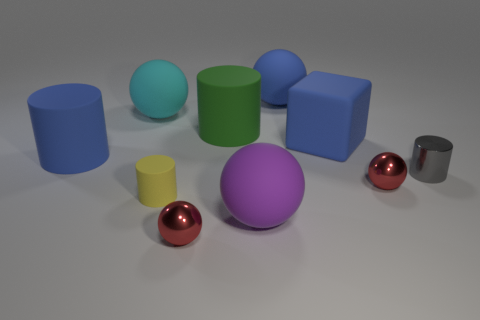Is the color of the block the same as the small shiny cylinder?
Provide a short and direct response. No. How many cyan matte cylinders are there?
Offer a very short reply. 0. There is a red thing in front of the matte sphere in front of the gray cylinder; what is its material?
Your answer should be very brief. Metal. There is a blue ball that is the same size as the purple sphere; what material is it?
Your answer should be compact. Rubber. There is a cylinder that is in front of the gray cylinder; is its size the same as the big cyan rubber sphere?
Make the answer very short. No. There is a tiny red shiny object behind the purple sphere; is its shape the same as the gray thing?
Your answer should be compact. No. What number of objects are metal cylinders or objects that are on the left side of the gray metallic cylinder?
Keep it short and to the point. 10. Are there fewer gray cylinders than small cyan cylinders?
Give a very brief answer. No. Is the number of tiny yellow cubes greater than the number of purple matte things?
Provide a succinct answer. No. How many other things are there of the same material as the large green cylinder?
Offer a terse response. 6. 